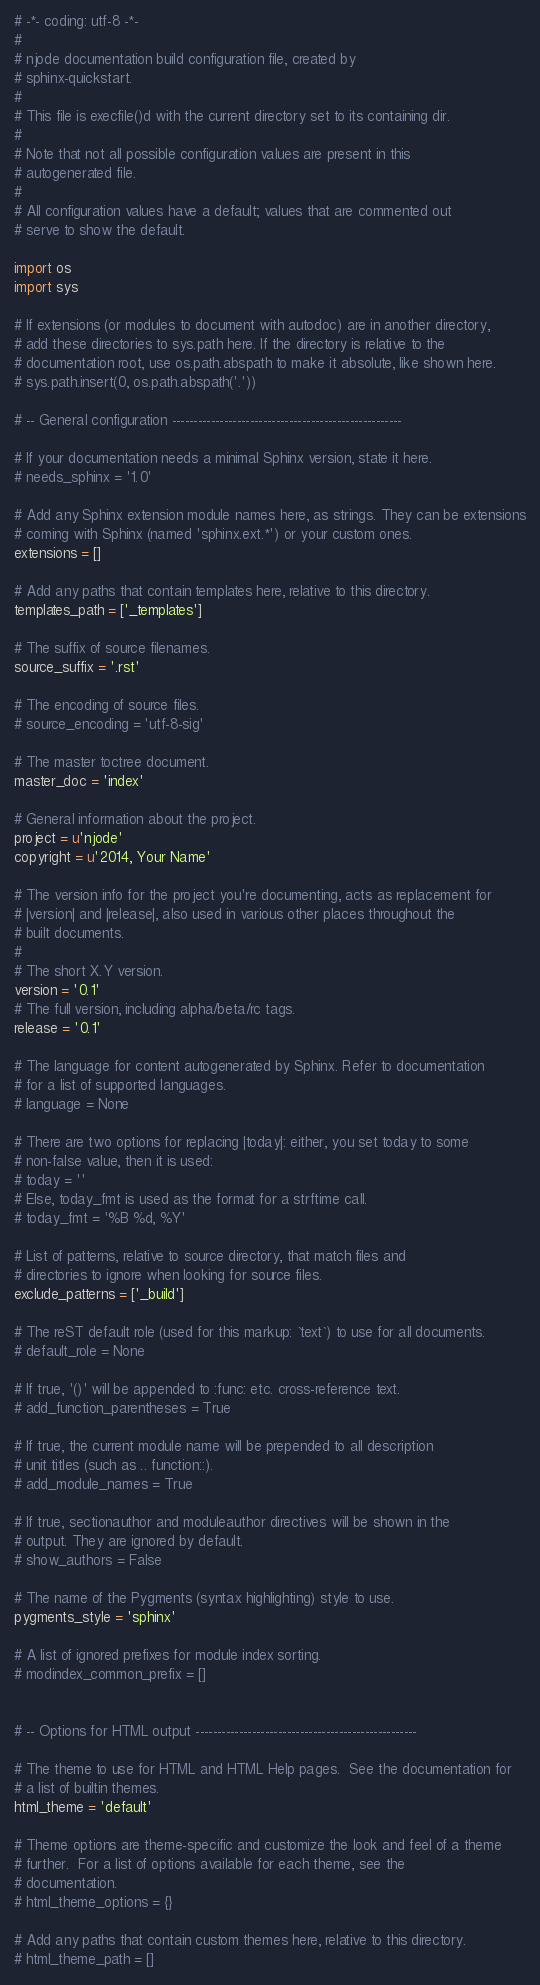Convert code to text. <code><loc_0><loc_0><loc_500><loc_500><_Python_># -*- coding: utf-8 -*-
#
# njode documentation build configuration file, created by
# sphinx-quickstart.
#
# This file is execfile()d with the current directory set to its containing dir.
#
# Note that not all possible configuration values are present in this
# autogenerated file.
#
# All configuration values have a default; values that are commented out
# serve to show the default.

import os
import sys

# If extensions (or modules to document with autodoc) are in another directory,
# add these directories to sys.path here. If the directory is relative to the
# documentation root, use os.path.abspath to make it absolute, like shown here.
# sys.path.insert(0, os.path.abspath('.'))

# -- General configuration -----------------------------------------------------

# If your documentation needs a minimal Sphinx version, state it here.
# needs_sphinx = '1.0'

# Add any Sphinx extension module names here, as strings. They can be extensions
# coming with Sphinx (named 'sphinx.ext.*') or your custom ones.
extensions = []

# Add any paths that contain templates here, relative to this directory.
templates_path = ['_templates']

# The suffix of source filenames.
source_suffix = '.rst'

# The encoding of source files.
# source_encoding = 'utf-8-sig'

# The master toctree document.
master_doc = 'index'

# General information about the project.
project = u'njode'
copyright = u'2014, Your Name'

# The version info for the project you're documenting, acts as replacement for
# |version| and |release|, also used in various other places throughout the
# built documents.
#
# The short X.Y version.
version = '0.1'
# The full version, including alpha/beta/rc tags.
release = '0.1'

# The language for content autogenerated by Sphinx. Refer to documentation
# for a list of supported languages.
# language = None

# There are two options for replacing |today|: either, you set today to some
# non-false value, then it is used:
# today = ''
# Else, today_fmt is used as the format for a strftime call.
# today_fmt = '%B %d, %Y'

# List of patterns, relative to source directory, that match files and
# directories to ignore when looking for source files.
exclude_patterns = ['_build']

# The reST default role (used for this markup: `text`) to use for all documents.
# default_role = None

# If true, '()' will be appended to :func: etc. cross-reference text.
# add_function_parentheses = True

# If true, the current module name will be prepended to all description
# unit titles (such as .. function::).
# add_module_names = True

# If true, sectionauthor and moduleauthor directives will be shown in the
# output. They are ignored by default.
# show_authors = False

# The name of the Pygments (syntax highlighting) style to use.
pygments_style = 'sphinx'

# A list of ignored prefixes for module index sorting.
# modindex_common_prefix = []


# -- Options for HTML output ---------------------------------------------------

# The theme to use for HTML and HTML Help pages.  See the documentation for
# a list of builtin themes.
html_theme = 'default'

# Theme options are theme-specific and customize the look and feel of a theme
# further.  For a list of options available for each theme, see the
# documentation.
# html_theme_options = {}

# Add any paths that contain custom themes here, relative to this directory.
# html_theme_path = []
</code> 